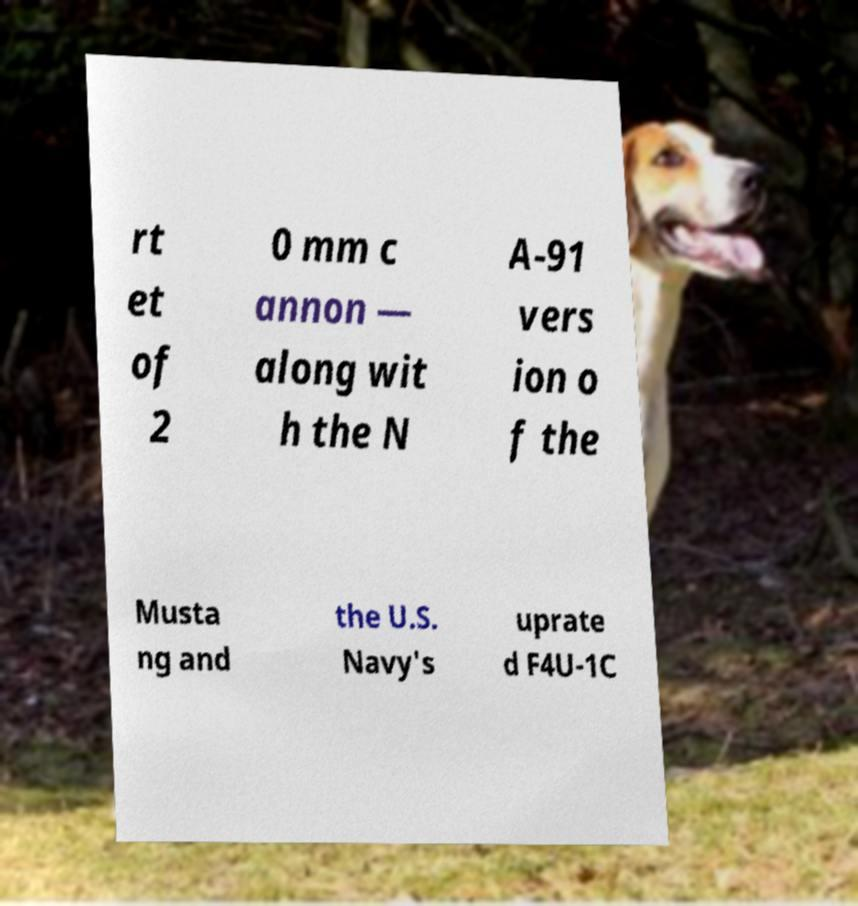Can you read and provide the text displayed in the image?This photo seems to have some interesting text. Can you extract and type it out for me? rt et of 2 0 mm c annon — along wit h the N A-91 vers ion o f the Musta ng and the U.S. Navy's uprate d F4U-1C 